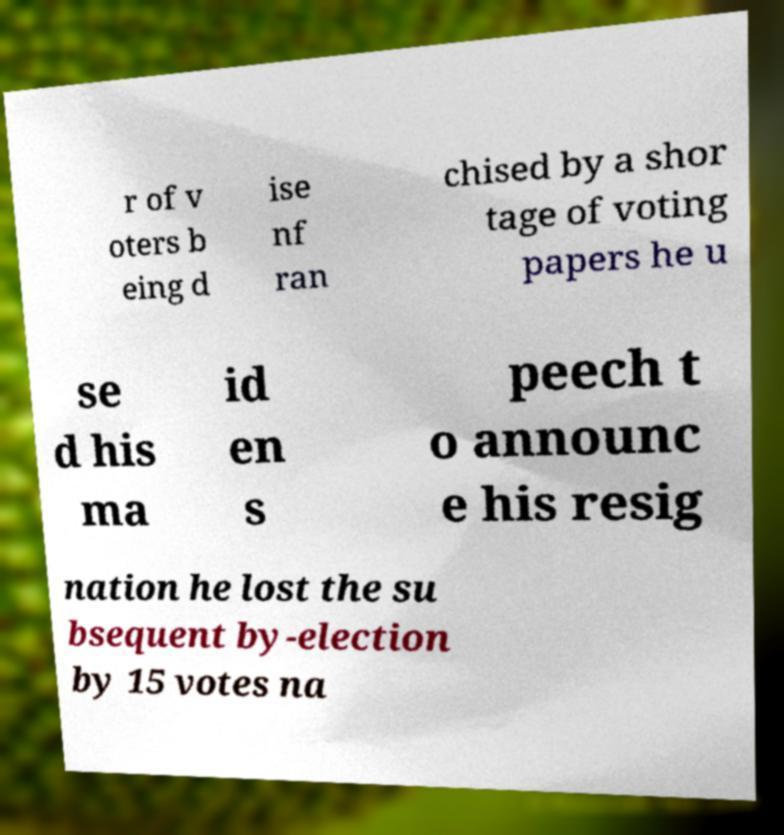Please read and relay the text visible in this image. What does it say? r of v oters b eing d ise nf ran chised by a shor tage of voting papers he u se d his ma id en s peech t o announc e his resig nation he lost the su bsequent by-election by 15 votes na 